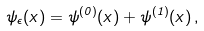Convert formula to latex. <formula><loc_0><loc_0><loc_500><loc_500>\psi _ { \epsilon } ( x ) = \psi ^ { ( 0 ) } ( x ) + \psi ^ { ( 1 ) } ( x ) \, ,</formula> 